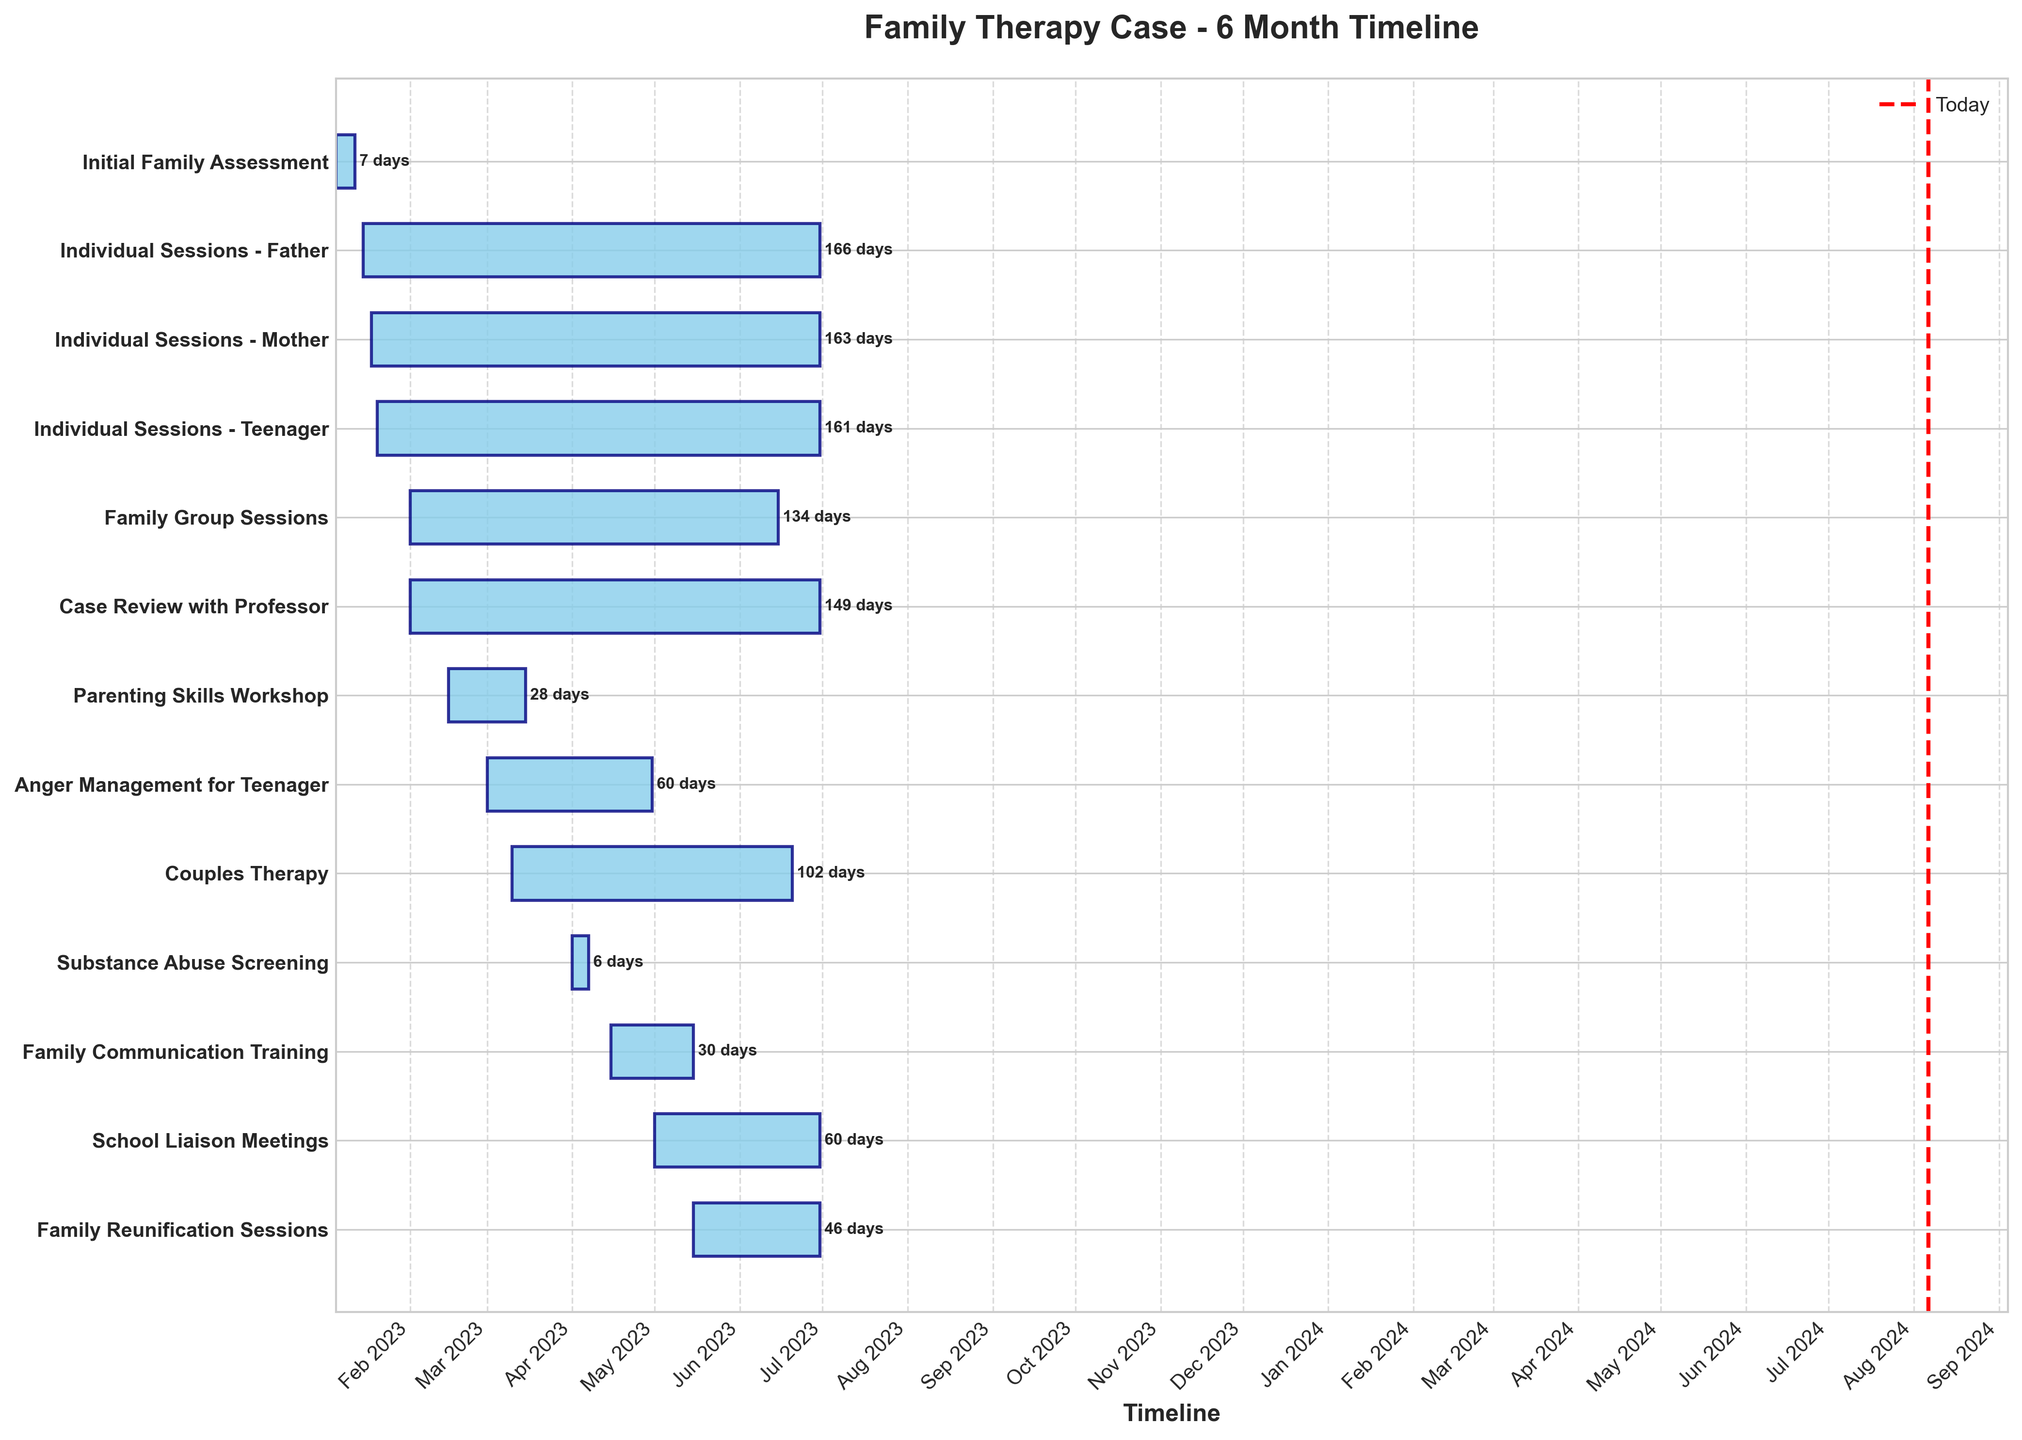What is the title of the plot? The title of the plot is displayed at the top center of the chart. It reads "Family Therapy Case - 6 Month Timeline."
Answer: Family Therapy Case - 6 Month Timeline Which task has the longest duration? To find the task with the longest duration, count the number of days between the start and end dates for each task. "Individual Sessions - Father," "Individual Sessions - Mother," and "Individual Sessions - Teenager" all run from mid-January to the end of June, lasting approximately 166 days.
Answer: Individual Sessions - Father, Individual Sessions - Mother, Individual Sessions - Teenager Which tasks are scheduled to start in February? Look at the start dates on the x-axis and find tasks with start dates in February. These tasks include "Family Group Sessions," "Parenting Skills Workshop," and "Case Review with Professor."
Answer: Family Group Sessions, Parenting Skills Workshop, Case Review with Professor How long does the "Parenting Skills Workshop" last? The "Parenting Skills Workshop" starts on February 15 and ends on March 15. The duration can be calculated by subtracting the start date from the end date: March 15 - February 15 = 29 days.
Answer: 29 days Compare the duration of "Family Group Sessions" and "Couples Therapy." Which one is longer? "Family Group Sessions" last from February 1 to June 15, totaling 134 days. "Couples Therapy" lasts from March 10 to June 20, totaling 102 days. Comparing these durations, "Family Group Sessions" is longer.
Answer: Family Group Sessions When does the "Substance Abuse Screening" task start and end? The "Substance Abuse Screening" task starts on April 1 and ends on April 7. This is depicted by a horizontal bar starting at April 1 and ending at April 7 on the x-axis.
Answer: April 1 to April 7 Which tasks continue through to the end of June? Tasks that have an end date of June 30 include "Individual Sessions - Father," "Individual Sessions - Mother," "Individual Sessions - Teenager," "School Liaison Meetings," and "Family Reunification Sessions."
Answer: Individual Sessions - Father, Individual Sessions - Mother, Individual Sessions - Teenager, School Liaison Meetings, Family Reunification Sessions What is the duration of the "Anger Management for Teenager" task? The "Anger Management for Teenager" task spans from March 1 to April 30. The duration can be calculated by subtracting the start date from the end date: April 30 - March 1 = 60 days.
Answer: 60 days Which task ends first and when? The "Initial Family Assessment" is the task that ends first. It ends on January 12, as indicated by its end date on the chart.
Answer: Initial Family Assessment What is today's date represented as on the chart, and how is it marked? Today's date is represented as a vertical red dashed line on the chart. The exact position will vary depending on the current date.
Answer: Vertical red dashed line 